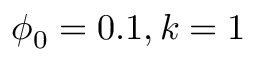<formula> <loc_0><loc_0><loc_500><loc_500>\phi _ { 0 } = 0 . 1 , k = 1</formula> 